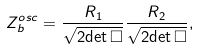Convert formula to latex. <formula><loc_0><loc_0><loc_500><loc_500>Z ^ { o s c } _ { b } = \frac { R _ { 1 } } { \sqrt { 2 { \det \Box } } } \frac { R _ { 2 } } { \sqrt { 2 { \det \Box } } } ,</formula> 